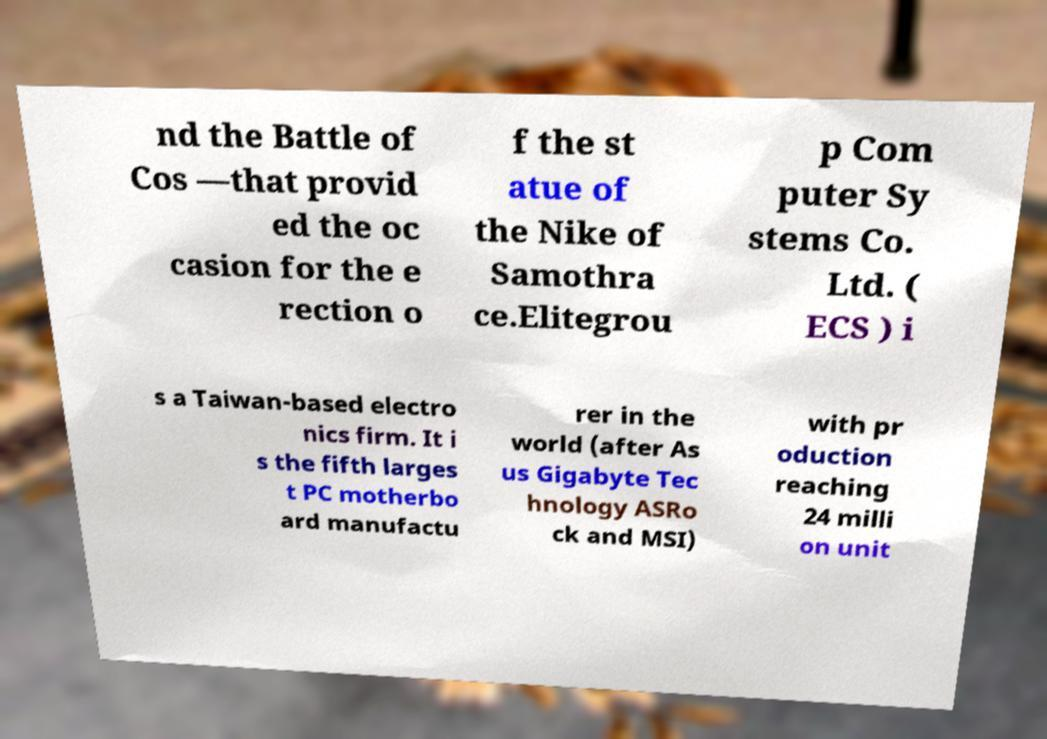Please read and relay the text visible in this image. What does it say? nd the Battle of Cos —that provid ed the oc casion for the e rection o f the st atue of the Nike of Samothra ce.Elitegrou p Com puter Sy stems Co. Ltd. ( ECS ) i s a Taiwan-based electro nics firm. It i s the fifth larges t PC motherbo ard manufactu rer in the world (after As us Gigabyte Tec hnology ASRo ck and MSI) with pr oduction reaching 24 milli on unit 